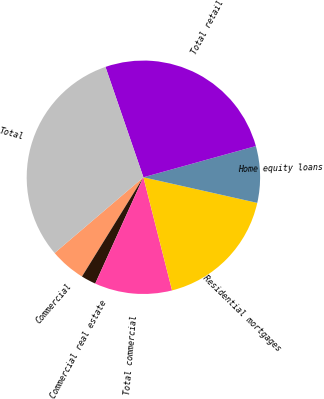<chart> <loc_0><loc_0><loc_500><loc_500><pie_chart><fcel>Commercial<fcel>Commercial real estate<fcel>Total commercial<fcel>Residential mortgages<fcel>Home equity loans<fcel>Total retail<fcel>Total<nl><fcel>4.94%<fcel>2.05%<fcel>10.72%<fcel>17.53%<fcel>7.83%<fcel>25.96%<fcel>30.97%<nl></chart> 